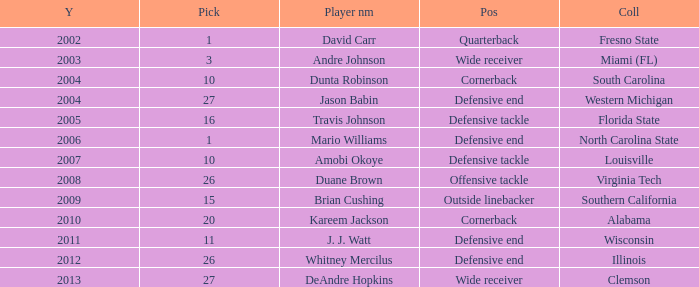What pick was mario williams before 2006? None. 